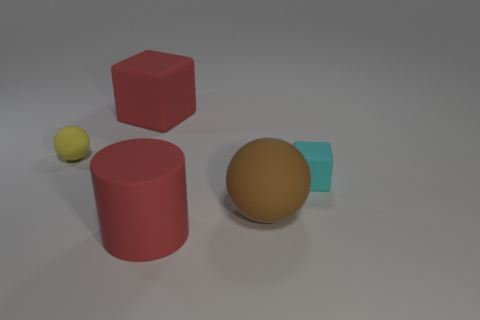Add 2 big objects. How many objects exist? 7 Subtract all spheres. How many objects are left? 3 Add 2 large cylinders. How many large cylinders exist? 3 Subtract 1 brown balls. How many objects are left? 4 Subtract all brown spheres. Subtract all small yellow balls. How many objects are left? 3 Add 5 yellow balls. How many yellow balls are left? 6 